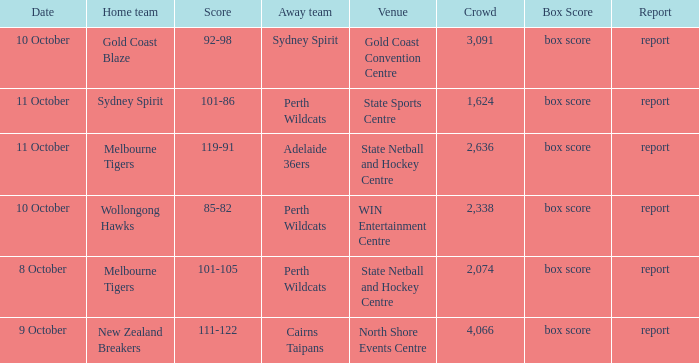What was the crowd size for the game with a score of 101-105? 2074.0. 